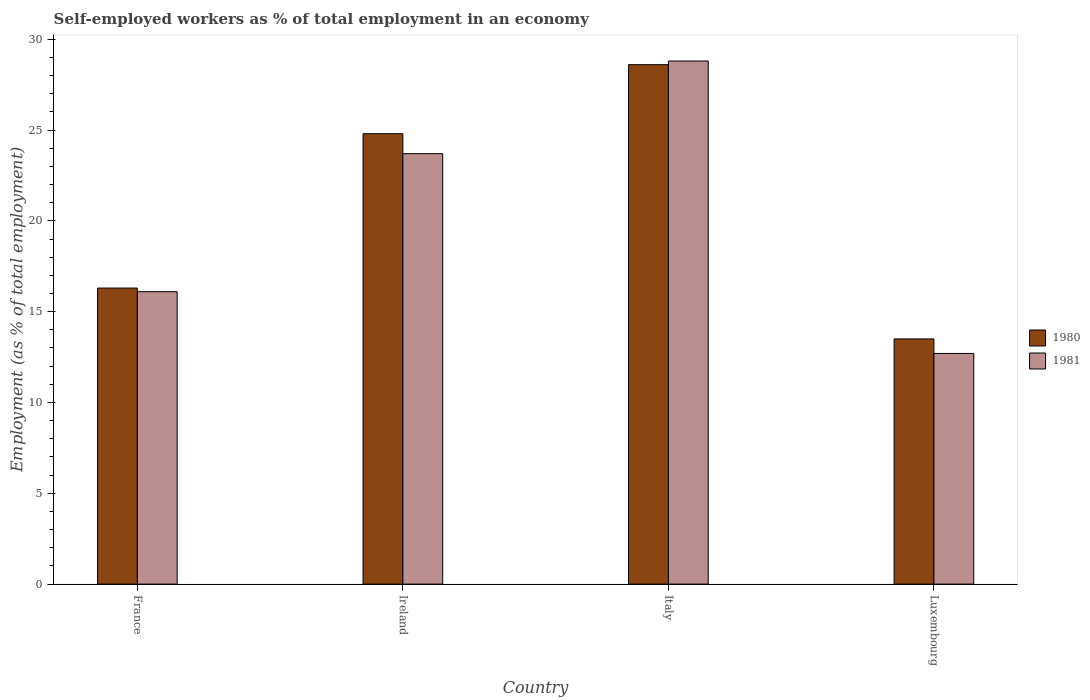How many different coloured bars are there?
Your answer should be very brief. 2. Are the number of bars per tick equal to the number of legend labels?
Your response must be concise. Yes. How many bars are there on the 4th tick from the right?
Offer a terse response. 2. What is the label of the 1st group of bars from the left?
Your answer should be compact. France. What is the percentage of self-employed workers in 1981 in Luxembourg?
Ensure brevity in your answer.  12.7. Across all countries, what is the maximum percentage of self-employed workers in 1981?
Give a very brief answer. 28.8. Across all countries, what is the minimum percentage of self-employed workers in 1980?
Give a very brief answer. 13.5. In which country was the percentage of self-employed workers in 1980 maximum?
Your answer should be compact. Italy. In which country was the percentage of self-employed workers in 1981 minimum?
Make the answer very short. Luxembourg. What is the total percentage of self-employed workers in 1981 in the graph?
Give a very brief answer. 81.3. What is the difference between the percentage of self-employed workers in 1981 in France and that in Luxembourg?
Make the answer very short. 3.4. What is the difference between the percentage of self-employed workers in 1981 in Luxembourg and the percentage of self-employed workers in 1980 in Italy?
Offer a terse response. -15.9. What is the average percentage of self-employed workers in 1981 per country?
Ensure brevity in your answer.  20.33. What is the difference between the percentage of self-employed workers of/in 1981 and percentage of self-employed workers of/in 1980 in Luxembourg?
Your answer should be compact. -0.8. What is the ratio of the percentage of self-employed workers in 1981 in France to that in Italy?
Ensure brevity in your answer.  0.56. Is the percentage of self-employed workers in 1981 in France less than that in Ireland?
Keep it short and to the point. Yes. What is the difference between the highest and the second highest percentage of self-employed workers in 1980?
Keep it short and to the point. 8.5. What is the difference between the highest and the lowest percentage of self-employed workers in 1980?
Provide a short and direct response. 15.1. Is the sum of the percentage of self-employed workers in 1981 in Ireland and Italy greater than the maximum percentage of self-employed workers in 1980 across all countries?
Your answer should be very brief. Yes. What does the 1st bar from the right in Italy represents?
Offer a very short reply. 1981. Are all the bars in the graph horizontal?
Your response must be concise. No. How many countries are there in the graph?
Make the answer very short. 4. What is the difference between two consecutive major ticks on the Y-axis?
Provide a short and direct response. 5. Are the values on the major ticks of Y-axis written in scientific E-notation?
Your answer should be compact. No. Does the graph contain any zero values?
Your answer should be compact. No. Where does the legend appear in the graph?
Your answer should be very brief. Center right. How many legend labels are there?
Provide a short and direct response. 2. What is the title of the graph?
Ensure brevity in your answer.  Self-employed workers as % of total employment in an economy. What is the label or title of the Y-axis?
Give a very brief answer. Employment (as % of total employment). What is the Employment (as % of total employment) of 1980 in France?
Give a very brief answer. 16.3. What is the Employment (as % of total employment) in 1981 in France?
Give a very brief answer. 16.1. What is the Employment (as % of total employment) of 1980 in Ireland?
Your answer should be very brief. 24.8. What is the Employment (as % of total employment) of 1981 in Ireland?
Keep it short and to the point. 23.7. What is the Employment (as % of total employment) of 1980 in Italy?
Keep it short and to the point. 28.6. What is the Employment (as % of total employment) of 1981 in Italy?
Ensure brevity in your answer.  28.8. What is the Employment (as % of total employment) in 1981 in Luxembourg?
Offer a very short reply. 12.7. Across all countries, what is the maximum Employment (as % of total employment) in 1980?
Keep it short and to the point. 28.6. Across all countries, what is the maximum Employment (as % of total employment) in 1981?
Give a very brief answer. 28.8. Across all countries, what is the minimum Employment (as % of total employment) of 1981?
Your answer should be compact. 12.7. What is the total Employment (as % of total employment) in 1980 in the graph?
Ensure brevity in your answer.  83.2. What is the total Employment (as % of total employment) of 1981 in the graph?
Provide a succinct answer. 81.3. What is the difference between the Employment (as % of total employment) in 1980 in France and that in Ireland?
Your answer should be very brief. -8.5. What is the difference between the Employment (as % of total employment) of 1981 in France and that in Luxembourg?
Offer a terse response. 3.4. What is the difference between the Employment (as % of total employment) of 1981 in Ireland and that in Italy?
Offer a terse response. -5.1. What is the difference between the Employment (as % of total employment) in 1980 in Ireland and that in Luxembourg?
Your answer should be compact. 11.3. What is the difference between the Employment (as % of total employment) in 1980 in France and the Employment (as % of total employment) in 1981 in Ireland?
Offer a very short reply. -7.4. What is the difference between the Employment (as % of total employment) in 1980 in Ireland and the Employment (as % of total employment) in 1981 in Italy?
Offer a terse response. -4. What is the difference between the Employment (as % of total employment) of 1980 in Italy and the Employment (as % of total employment) of 1981 in Luxembourg?
Your response must be concise. 15.9. What is the average Employment (as % of total employment) of 1980 per country?
Provide a succinct answer. 20.8. What is the average Employment (as % of total employment) of 1981 per country?
Keep it short and to the point. 20.32. What is the difference between the Employment (as % of total employment) of 1980 and Employment (as % of total employment) of 1981 in France?
Your response must be concise. 0.2. What is the difference between the Employment (as % of total employment) of 1980 and Employment (as % of total employment) of 1981 in Ireland?
Offer a very short reply. 1.1. What is the difference between the Employment (as % of total employment) of 1980 and Employment (as % of total employment) of 1981 in Italy?
Give a very brief answer. -0.2. What is the difference between the Employment (as % of total employment) in 1980 and Employment (as % of total employment) in 1981 in Luxembourg?
Provide a succinct answer. 0.8. What is the ratio of the Employment (as % of total employment) in 1980 in France to that in Ireland?
Your response must be concise. 0.66. What is the ratio of the Employment (as % of total employment) of 1981 in France to that in Ireland?
Your response must be concise. 0.68. What is the ratio of the Employment (as % of total employment) of 1980 in France to that in Italy?
Give a very brief answer. 0.57. What is the ratio of the Employment (as % of total employment) of 1981 in France to that in Italy?
Keep it short and to the point. 0.56. What is the ratio of the Employment (as % of total employment) of 1980 in France to that in Luxembourg?
Offer a terse response. 1.21. What is the ratio of the Employment (as % of total employment) in 1981 in France to that in Luxembourg?
Provide a short and direct response. 1.27. What is the ratio of the Employment (as % of total employment) in 1980 in Ireland to that in Italy?
Give a very brief answer. 0.87. What is the ratio of the Employment (as % of total employment) in 1981 in Ireland to that in Italy?
Ensure brevity in your answer.  0.82. What is the ratio of the Employment (as % of total employment) in 1980 in Ireland to that in Luxembourg?
Your response must be concise. 1.84. What is the ratio of the Employment (as % of total employment) of 1981 in Ireland to that in Luxembourg?
Give a very brief answer. 1.87. What is the ratio of the Employment (as % of total employment) in 1980 in Italy to that in Luxembourg?
Make the answer very short. 2.12. What is the ratio of the Employment (as % of total employment) in 1981 in Italy to that in Luxembourg?
Your response must be concise. 2.27. What is the difference between the highest and the second highest Employment (as % of total employment) of 1981?
Offer a terse response. 5.1. 